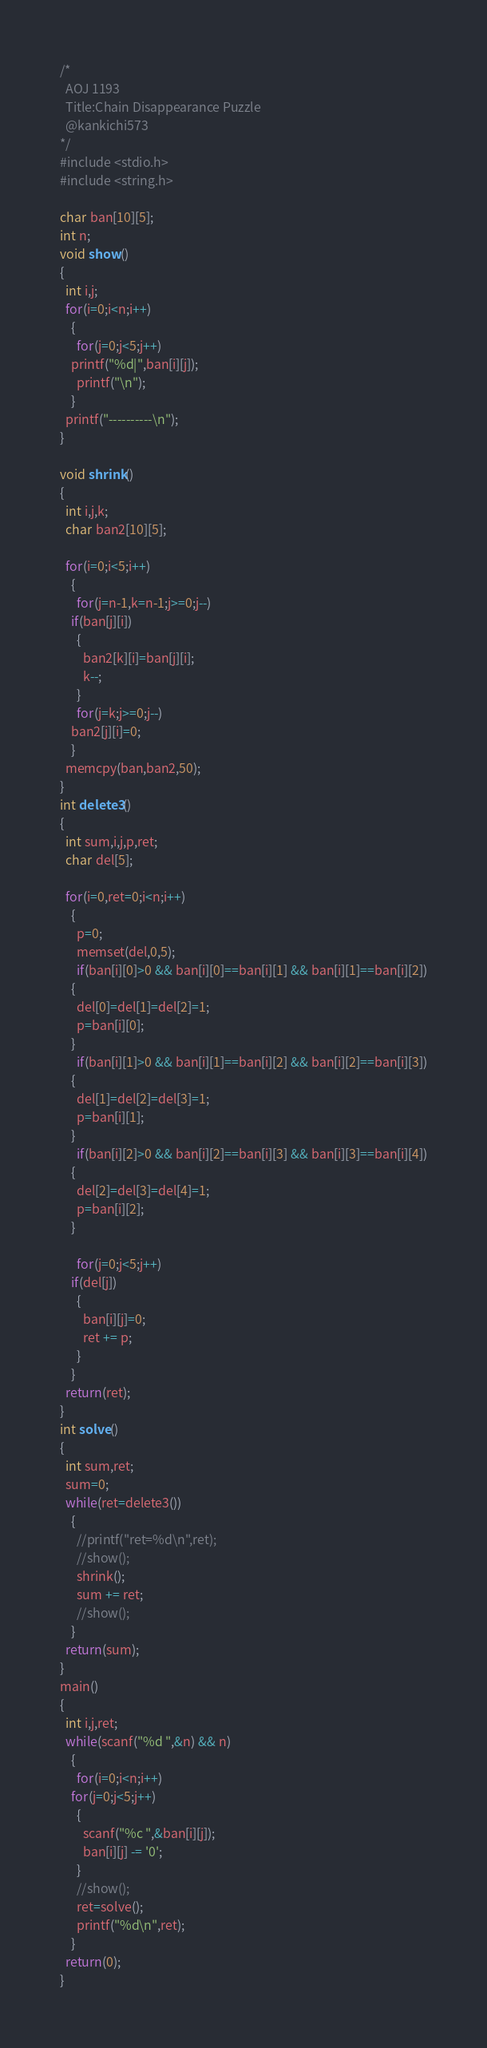Convert code to text. <code><loc_0><loc_0><loc_500><loc_500><_C_>/*
  AOJ 1193
  Title:Chain Disappearance Puzzle
  @kankichi573
*/
#include <stdio.h>
#include <string.h>

char ban[10][5];
int n;
void show()
{
  int i,j;
  for(i=0;i<n;i++)
    {
      for(j=0;j<5;j++)
	printf("%d|",ban[i][j]);
      printf("\n");
    }
  printf("----------\n");
}

void shrink()
{
  int i,j,k;
  char ban2[10][5];

  for(i=0;i<5;i++)
    {
      for(j=n-1,k=n-1;j>=0;j--)
	if(ban[j][i])
	  {
	    ban2[k][i]=ban[j][i];
	    k--;
	  }
      for(j=k;j>=0;j--)
	ban2[j][i]=0;
    }
  memcpy(ban,ban2,50);
}
int delete3()
{
  int sum,i,j,p,ret;
  char del[5];

  for(i=0,ret=0;i<n;i++)
    {
      p=0;
      memset(del,0,5);
      if(ban[i][0]>0 && ban[i][0]==ban[i][1] && ban[i][1]==ban[i][2])
	{
	  del[0]=del[1]=del[2]=1;
	  p=ban[i][0];
	}
      if(ban[i][1]>0 && ban[i][1]==ban[i][2] && ban[i][2]==ban[i][3])
	{
	  del[1]=del[2]=del[3]=1;
	  p=ban[i][1];
	}
      if(ban[i][2]>0 && ban[i][2]==ban[i][3] && ban[i][3]==ban[i][4])
	{
	  del[2]=del[3]=del[4]=1;
	  p=ban[i][2];
	}
    
      for(j=0;j<5;j++)
	if(del[j])
	  {
	    ban[i][j]=0;
	    ret += p;
	  }
    }
  return(ret);
}
int solve()
{
  int sum,ret;
  sum=0;
  while(ret=delete3())
    {
      //printf("ret=%d\n",ret);
      //show();
      shrink();
      sum += ret;
      //show();
    }
  return(sum);
}
main()
{
  int i,j,ret;
  while(scanf("%d ",&n) && n)
    {
      for(i=0;i<n;i++)
	for(j=0;j<5;j++)
	  {
	    scanf("%c ",&ban[i][j]);
	    ban[i][j] -= '0';
	  }
      //show();
      ret=solve();
      printf("%d\n",ret);
    }
  return(0);
}</code> 